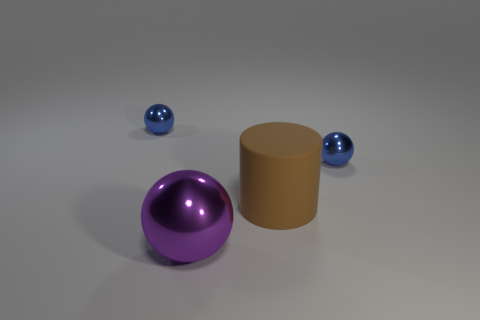How many other objects are the same color as the matte cylinder?
Provide a succinct answer. 0. There is a large metallic ball; does it have the same color as the ball to the left of the purple ball?
Your answer should be compact. No. What number of blue objects are either metallic things or big objects?
Provide a succinct answer. 2. Are there the same number of big purple balls that are right of the cylinder and cyan metallic balls?
Offer a terse response. Yes. Are there any other things that have the same size as the purple shiny thing?
Your response must be concise. Yes. What number of other big brown things are the same shape as the big brown matte thing?
Give a very brief answer. 0. How many small things are there?
Provide a short and direct response. 2. Are there any blue balls made of the same material as the cylinder?
Keep it short and to the point. No. There is a shiny ball that is in front of the matte object; is its size the same as the blue sphere that is on the right side of the large metallic object?
Your answer should be compact. No. What is the size of the metal ball on the left side of the purple metallic sphere?
Ensure brevity in your answer.  Small. 